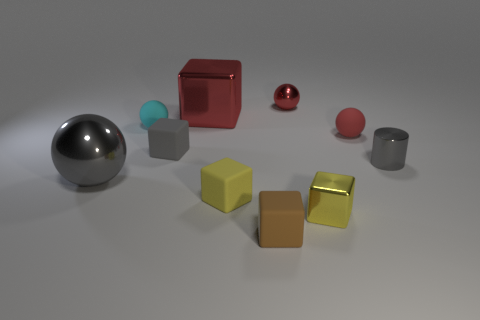Is there any other thing that is the same shape as the small gray metallic thing?
Your answer should be very brief. No. Is the color of the large sphere the same as the small block that is on the right side of the tiny red shiny thing?
Provide a succinct answer. No. What shape is the red object that is made of the same material as the cyan object?
Your answer should be compact. Sphere. There is a gray shiny thing that is on the right side of the large shiny sphere; is its shape the same as the yellow rubber thing?
Offer a very short reply. No. There is a gray object right of the metal ball that is on the right side of the gray sphere; how big is it?
Provide a succinct answer. Small. What is the color of the small ball that is the same material as the big gray object?
Ensure brevity in your answer.  Red. What number of yellow shiny cubes have the same size as the gray cube?
Ensure brevity in your answer.  1. What number of red objects are tiny shiny balls or spheres?
Ensure brevity in your answer.  2. How many objects are either big red shiny balls or large red metallic cubes that are behind the large ball?
Your response must be concise. 1. There is a yellow block that is in front of the yellow rubber object; what is its material?
Give a very brief answer. Metal. 